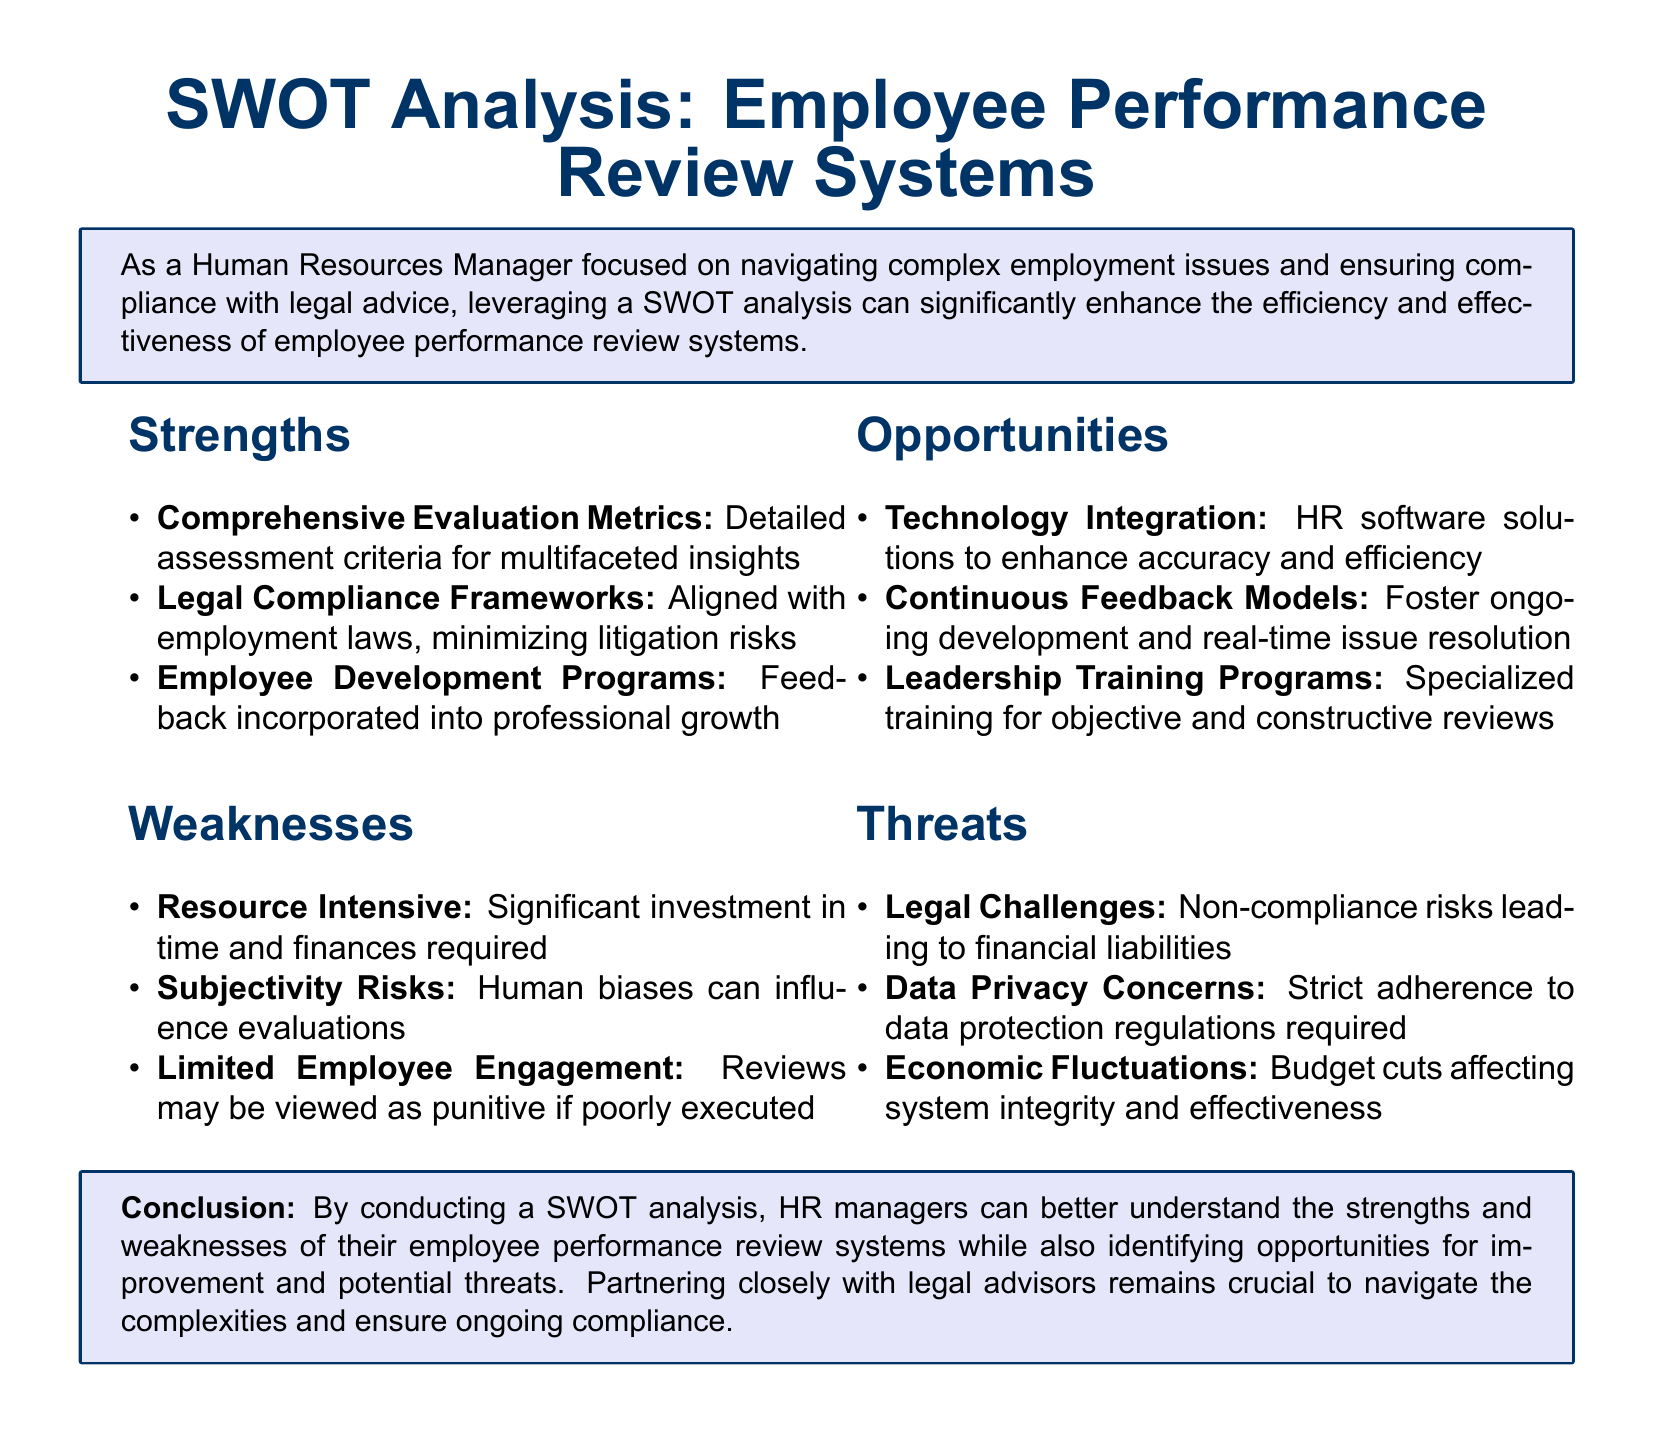What are the comprehensive evaluation metrics? The comprehensive evaluation metrics refer to the detailed assessment criteria for multifaceted insights listed under strengths.
Answer: Detailed assessment criteria for multifaceted insights How many weaknesses are identified? The weaknesses are listed under a specific section, and counting them provides the total.
Answer: Three What opportunity involves HR software solutions? The specific opportunity mentions the inclusion of HR software solutions to improve aspects of the performance review.
Answer: Technology Integration What is a potential threat related to law? The document specifically mentions one of the threats as a risk associated with non-compliance with legal standards.
Answer: Legal Challenges What does the legal compliance framework minimize? The legal compliance framework is stated in the document to minimize risks associated with laws and regulations.
Answer: Litigation risks What is the focus of the conclusion? The conclusion focuses on the purpose and benefit of conducting a SWOT analysis in managing employee performance review systems.
Answer: Understanding strengths and weaknesses What model fosters ongoing development? The document specifies that a particular model encourages ongoing development and issue resolution among employees.
Answer: Continuous Feedback Models What risk factor is financial-related? The document outlines a specific threat related to budget management that could impact the performance review system.
Answer: Economic Fluctuations 